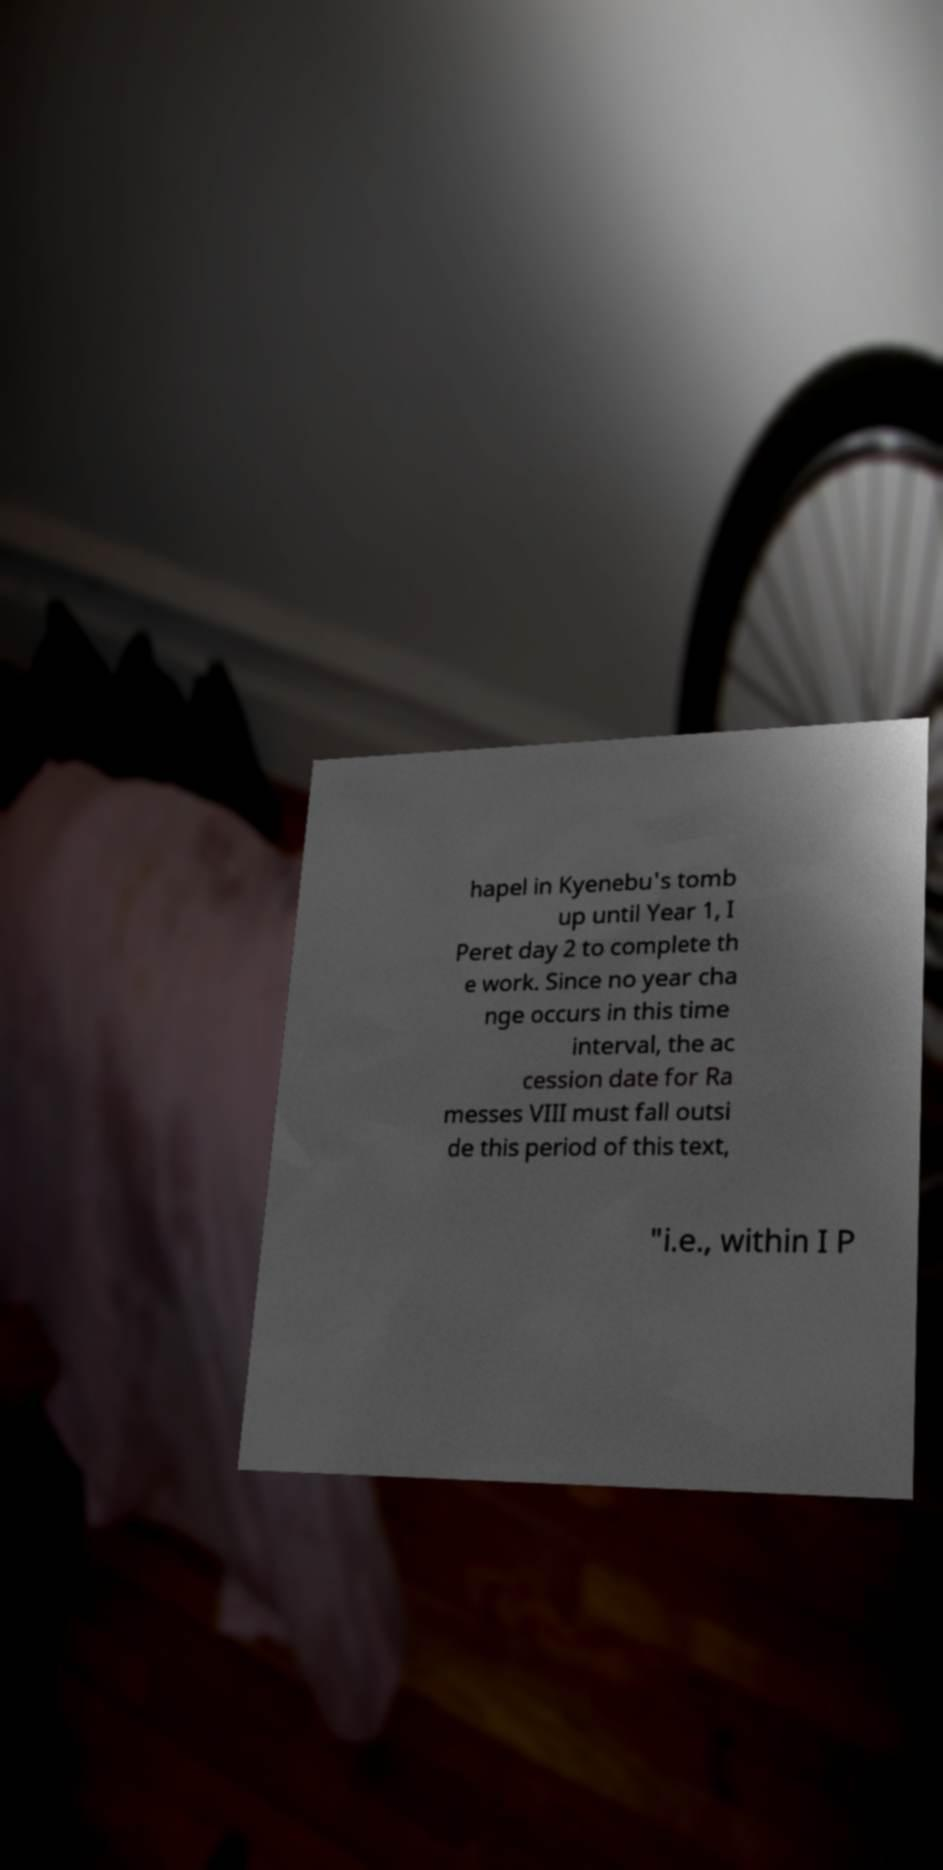I need the written content from this picture converted into text. Can you do that? hapel in Kyenebu's tomb up until Year 1, I Peret day 2 to complete th e work. Since no year cha nge occurs in this time interval, the ac cession date for Ra messes VIII must fall outsi de this period of this text, "i.e., within I P 